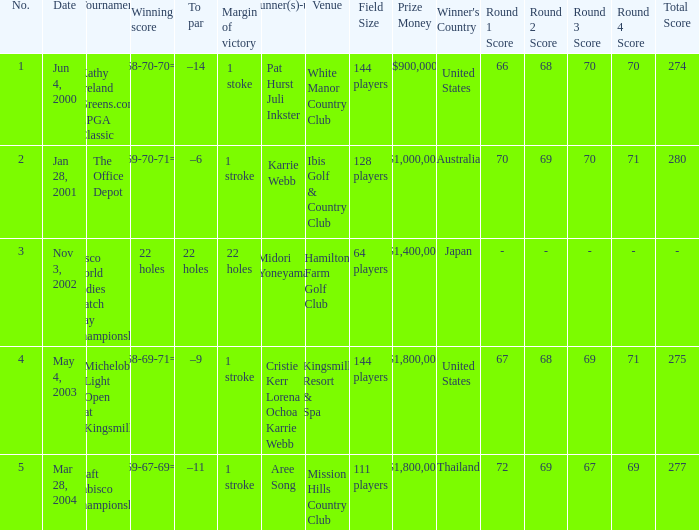What date were the runner ups pat hurst juli inkster? Jun 4, 2000. 